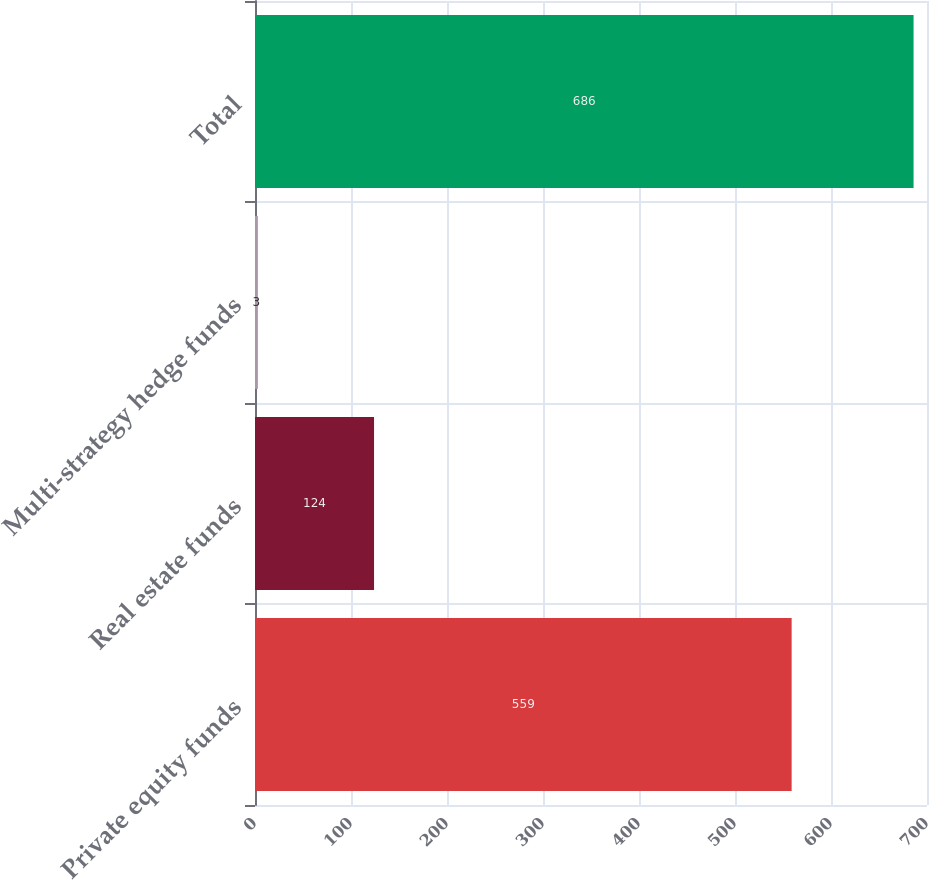<chart> <loc_0><loc_0><loc_500><loc_500><bar_chart><fcel>Private equity funds<fcel>Real estate funds<fcel>Multi-strategy hedge funds<fcel>Total<nl><fcel>559<fcel>124<fcel>3<fcel>686<nl></chart> 